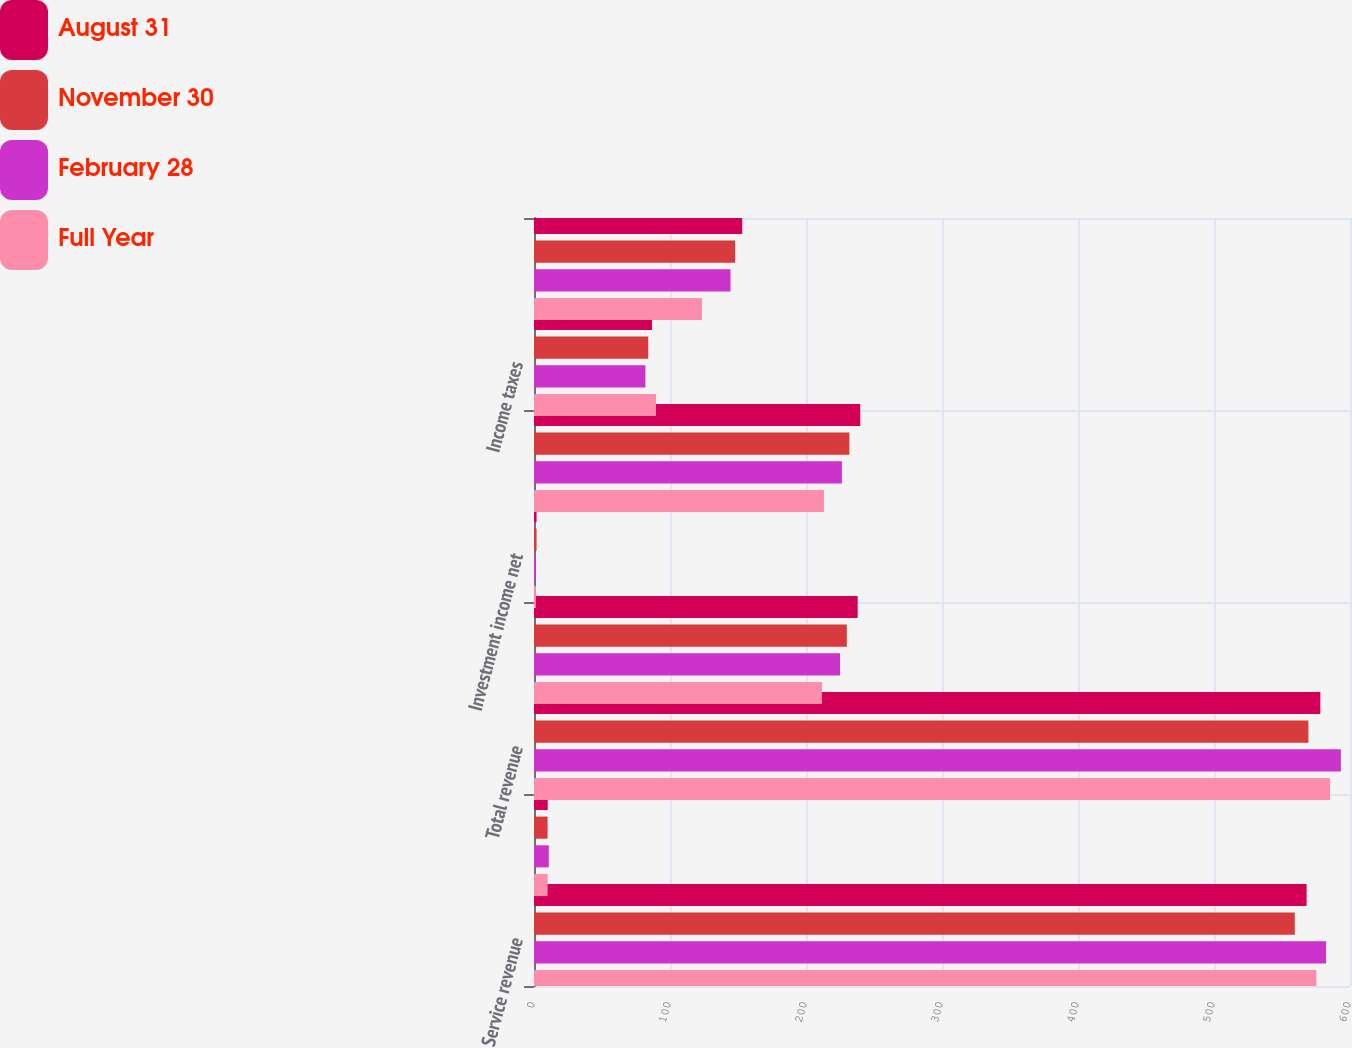<chart> <loc_0><loc_0><loc_500><loc_500><stacked_bar_chart><ecel><fcel>Service revenue<fcel>Interest on funds held for<fcel>Total revenue<fcel>Operating income<fcel>Investment income net<fcel>Income before income taxes<fcel>Income taxes<fcel>Net income<nl><fcel>August 31<fcel>568.1<fcel>10.1<fcel>578.2<fcel>238<fcel>1.9<fcel>239.9<fcel>86.8<fcel>153.1<nl><fcel>November 30<fcel>559.4<fcel>10<fcel>569.4<fcel>230<fcel>1.9<fcel>231.9<fcel>84<fcel>147.9<nl><fcel>February 28<fcel>582.4<fcel>10.9<fcel>593.3<fcel>225<fcel>1.4<fcel>226.4<fcel>81.9<fcel>144.5<nl><fcel>Full Year<fcel>575.3<fcel>10<fcel>585.3<fcel>211.8<fcel>1.4<fcel>213.2<fcel>89.7<fcel>123.5<nl></chart> 